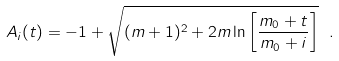<formula> <loc_0><loc_0><loc_500><loc_500>A _ { i } ( t ) = - 1 + \sqrt { ( m + 1 ) ^ { 2 } + 2 m \ln \left [ \frac { m _ { 0 } + t } { m _ { 0 } + i } \right ] } \ .</formula> 